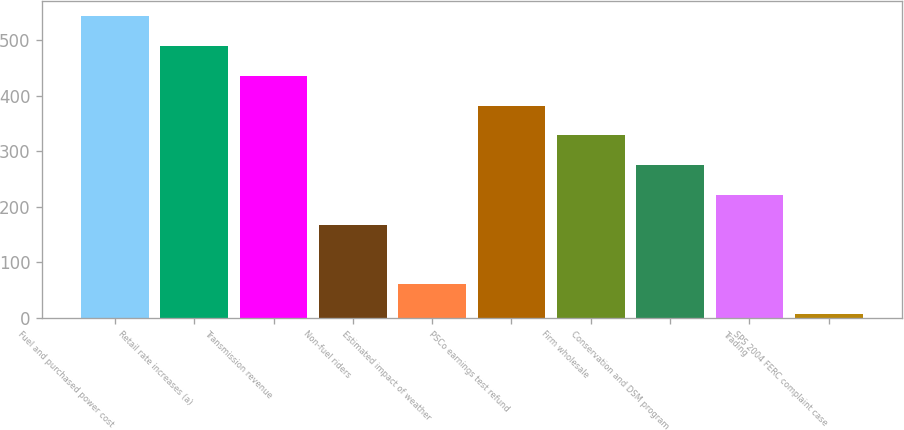Convert chart. <chart><loc_0><loc_0><loc_500><loc_500><bar_chart><fcel>Fuel and purchased power cost<fcel>Retail rate increases (a)<fcel>Transmission revenue<fcel>Non-fuel riders<fcel>Estimated impact of weather<fcel>PSCo earnings test refund<fcel>Firm wholesale<fcel>Conservation and DSM program<fcel>Trading<fcel>SPS 2004 FERC complaint case<nl><fcel>543<fcel>489.3<fcel>435.6<fcel>167.1<fcel>59.7<fcel>381.9<fcel>328.2<fcel>274.5<fcel>220.8<fcel>6<nl></chart> 